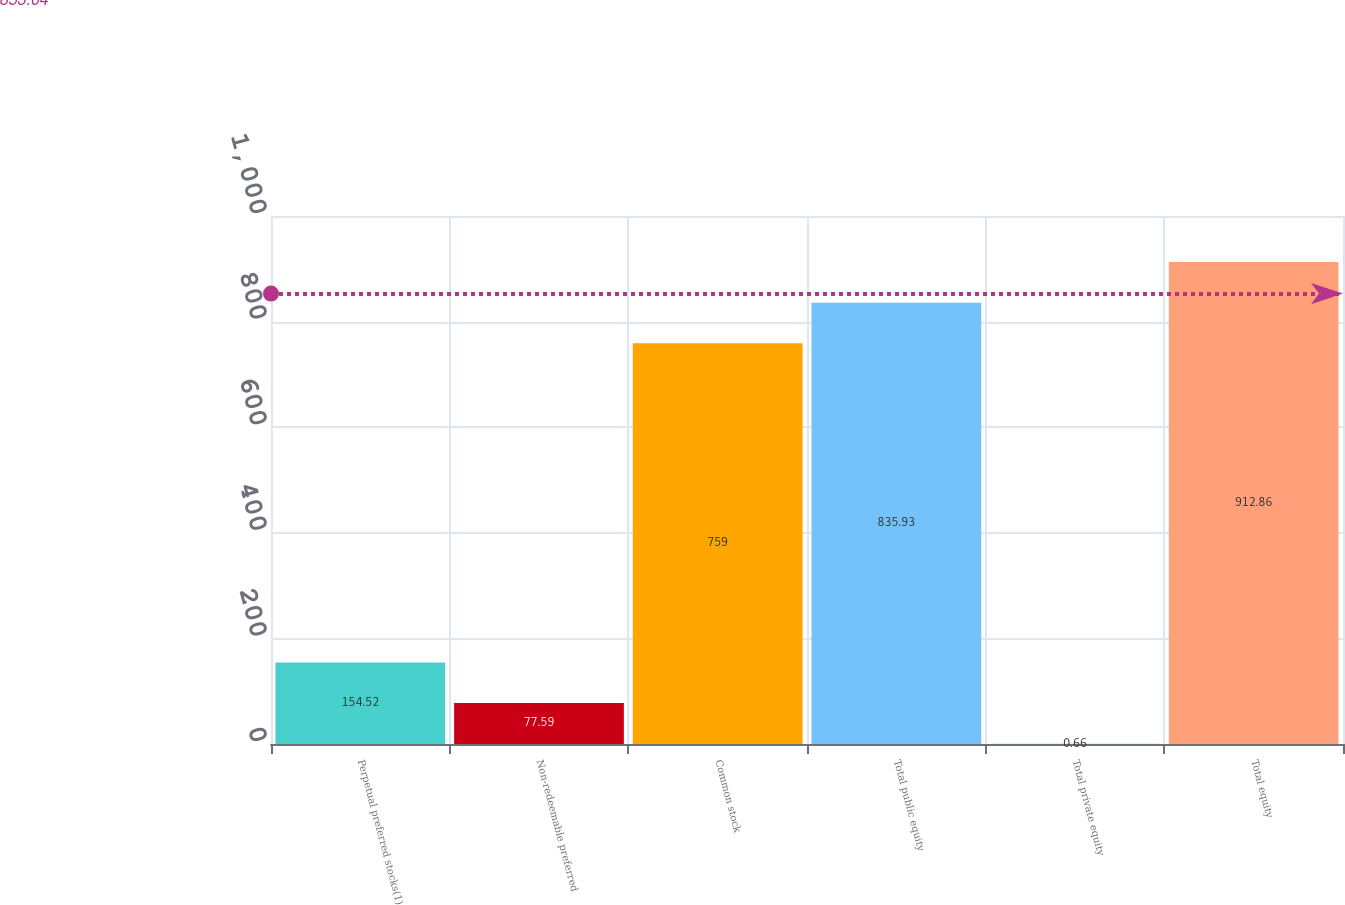<chart> <loc_0><loc_0><loc_500><loc_500><bar_chart><fcel>Perpetual preferred stocks(1)<fcel>Non-redeemable preferred<fcel>Common stock<fcel>Total public equity<fcel>Total private equity<fcel>Total equity<nl><fcel>154.52<fcel>77.59<fcel>759<fcel>835.93<fcel>0.66<fcel>912.86<nl></chart> 